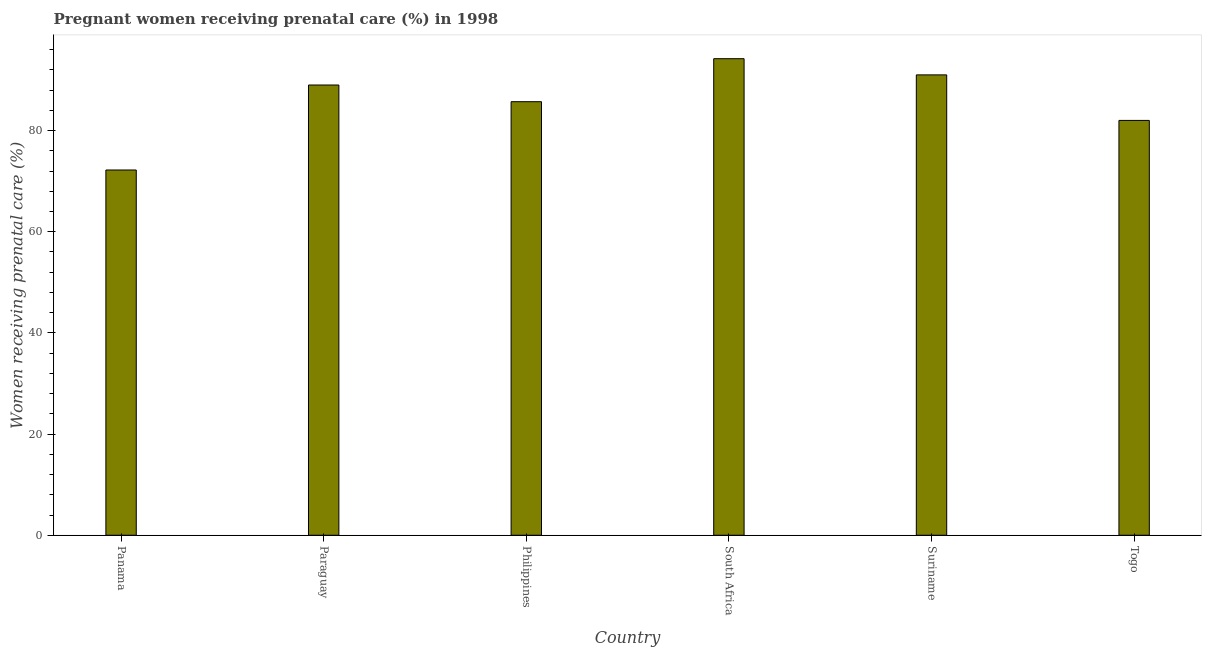Does the graph contain grids?
Your response must be concise. No. What is the title of the graph?
Your response must be concise. Pregnant women receiving prenatal care (%) in 1998. What is the label or title of the Y-axis?
Provide a succinct answer. Women receiving prenatal care (%). What is the percentage of pregnant women receiving prenatal care in Philippines?
Provide a succinct answer. 85.7. Across all countries, what is the maximum percentage of pregnant women receiving prenatal care?
Provide a succinct answer. 94.2. Across all countries, what is the minimum percentage of pregnant women receiving prenatal care?
Provide a succinct answer. 72.2. In which country was the percentage of pregnant women receiving prenatal care maximum?
Offer a very short reply. South Africa. In which country was the percentage of pregnant women receiving prenatal care minimum?
Provide a succinct answer. Panama. What is the sum of the percentage of pregnant women receiving prenatal care?
Make the answer very short. 514.1. What is the average percentage of pregnant women receiving prenatal care per country?
Your answer should be very brief. 85.68. What is the median percentage of pregnant women receiving prenatal care?
Provide a short and direct response. 87.35. In how many countries, is the percentage of pregnant women receiving prenatal care greater than 68 %?
Provide a short and direct response. 6. What is the ratio of the percentage of pregnant women receiving prenatal care in Panama to that in Philippines?
Give a very brief answer. 0.84. Is the percentage of pregnant women receiving prenatal care in Philippines less than that in Suriname?
Offer a very short reply. Yes. Is the sum of the percentage of pregnant women receiving prenatal care in Paraguay and South Africa greater than the maximum percentage of pregnant women receiving prenatal care across all countries?
Provide a short and direct response. Yes. What is the difference between the highest and the lowest percentage of pregnant women receiving prenatal care?
Make the answer very short. 22. In how many countries, is the percentage of pregnant women receiving prenatal care greater than the average percentage of pregnant women receiving prenatal care taken over all countries?
Provide a short and direct response. 4. Are all the bars in the graph horizontal?
Provide a short and direct response. No. How many countries are there in the graph?
Offer a very short reply. 6. What is the difference between two consecutive major ticks on the Y-axis?
Provide a short and direct response. 20. What is the Women receiving prenatal care (%) of Panama?
Ensure brevity in your answer.  72.2. What is the Women receiving prenatal care (%) of Paraguay?
Your answer should be compact. 89. What is the Women receiving prenatal care (%) of Philippines?
Offer a very short reply. 85.7. What is the Women receiving prenatal care (%) in South Africa?
Ensure brevity in your answer.  94.2. What is the Women receiving prenatal care (%) of Suriname?
Keep it short and to the point. 91. What is the difference between the Women receiving prenatal care (%) in Panama and Paraguay?
Make the answer very short. -16.8. What is the difference between the Women receiving prenatal care (%) in Panama and Suriname?
Your answer should be compact. -18.8. What is the difference between the Women receiving prenatal care (%) in Paraguay and Philippines?
Offer a very short reply. 3.3. What is the difference between the Women receiving prenatal care (%) in Paraguay and South Africa?
Your answer should be compact. -5.2. What is the difference between the Women receiving prenatal care (%) in Philippines and South Africa?
Offer a terse response. -8.5. What is the difference between the Women receiving prenatal care (%) in Philippines and Suriname?
Provide a succinct answer. -5.3. What is the difference between the Women receiving prenatal care (%) in South Africa and Suriname?
Offer a terse response. 3.2. What is the ratio of the Women receiving prenatal care (%) in Panama to that in Paraguay?
Make the answer very short. 0.81. What is the ratio of the Women receiving prenatal care (%) in Panama to that in Philippines?
Keep it short and to the point. 0.84. What is the ratio of the Women receiving prenatal care (%) in Panama to that in South Africa?
Your answer should be very brief. 0.77. What is the ratio of the Women receiving prenatal care (%) in Panama to that in Suriname?
Your response must be concise. 0.79. What is the ratio of the Women receiving prenatal care (%) in Panama to that in Togo?
Offer a terse response. 0.88. What is the ratio of the Women receiving prenatal care (%) in Paraguay to that in Philippines?
Keep it short and to the point. 1.04. What is the ratio of the Women receiving prenatal care (%) in Paraguay to that in South Africa?
Make the answer very short. 0.94. What is the ratio of the Women receiving prenatal care (%) in Paraguay to that in Suriname?
Make the answer very short. 0.98. What is the ratio of the Women receiving prenatal care (%) in Paraguay to that in Togo?
Your answer should be very brief. 1.08. What is the ratio of the Women receiving prenatal care (%) in Philippines to that in South Africa?
Keep it short and to the point. 0.91. What is the ratio of the Women receiving prenatal care (%) in Philippines to that in Suriname?
Your response must be concise. 0.94. What is the ratio of the Women receiving prenatal care (%) in Philippines to that in Togo?
Provide a short and direct response. 1.04. What is the ratio of the Women receiving prenatal care (%) in South Africa to that in Suriname?
Offer a very short reply. 1.03. What is the ratio of the Women receiving prenatal care (%) in South Africa to that in Togo?
Keep it short and to the point. 1.15. What is the ratio of the Women receiving prenatal care (%) in Suriname to that in Togo?
Provide a succinct answer. 1.11. 